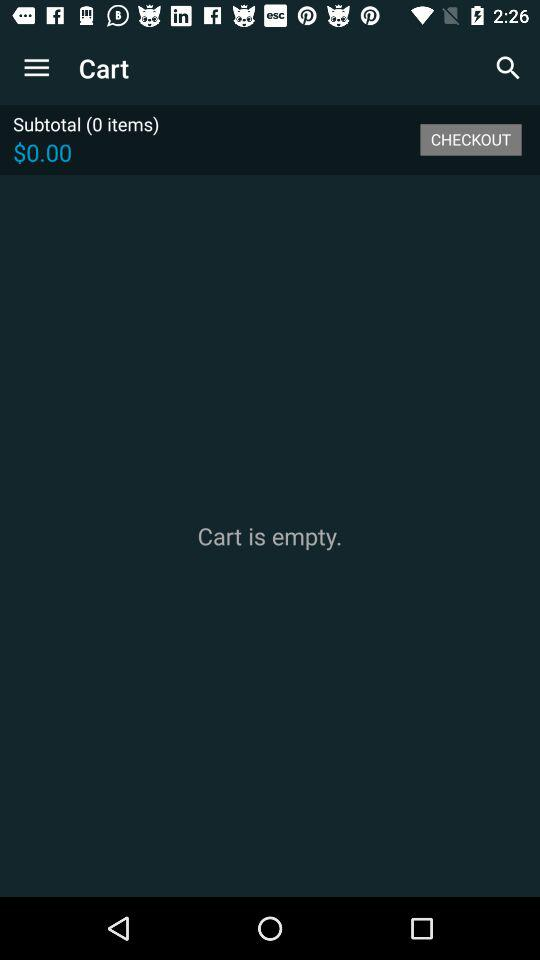How much does the cart total?
Answer the question using a single word or phrase. $0.00 